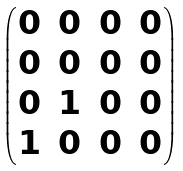<formula> <loc_0><loc_0><loc_500><loc_500>\begin{pmatrix} 0 & 0 & 0 & 0 \\ 0 & 0 & 0 & 0 \\ 0 & 1 & 0 & 0 \\ 1 & 0 & 0 & 0 \end{pmatrix}</formula> 